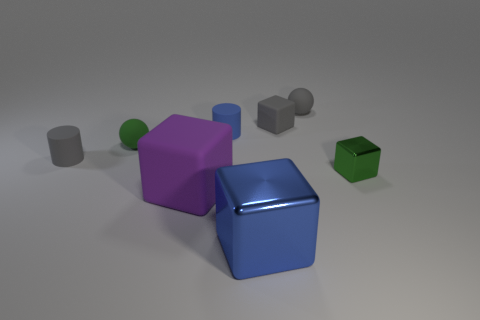Subtract all purple cubes. How many cubes are left? 3 Add 1 tiny yellow matte spheres. How many objects exist? 9 Subtract all green blocks. How many blocks are left? 3 Subtract all cylinders. How many objects are left? 6 Subtract all brown spheres. Subtract all green cubes. How many objects are left? 7 Add 6 metal things. How many metal things are left? 8 Add 4 gray blocks. How many gray blocks exist? 5 Subtract 0 brown blocks. How many objects are left? 8 Subtract all blue cubes. Subtract all cyan cylinders. How many cubes are left? 3 